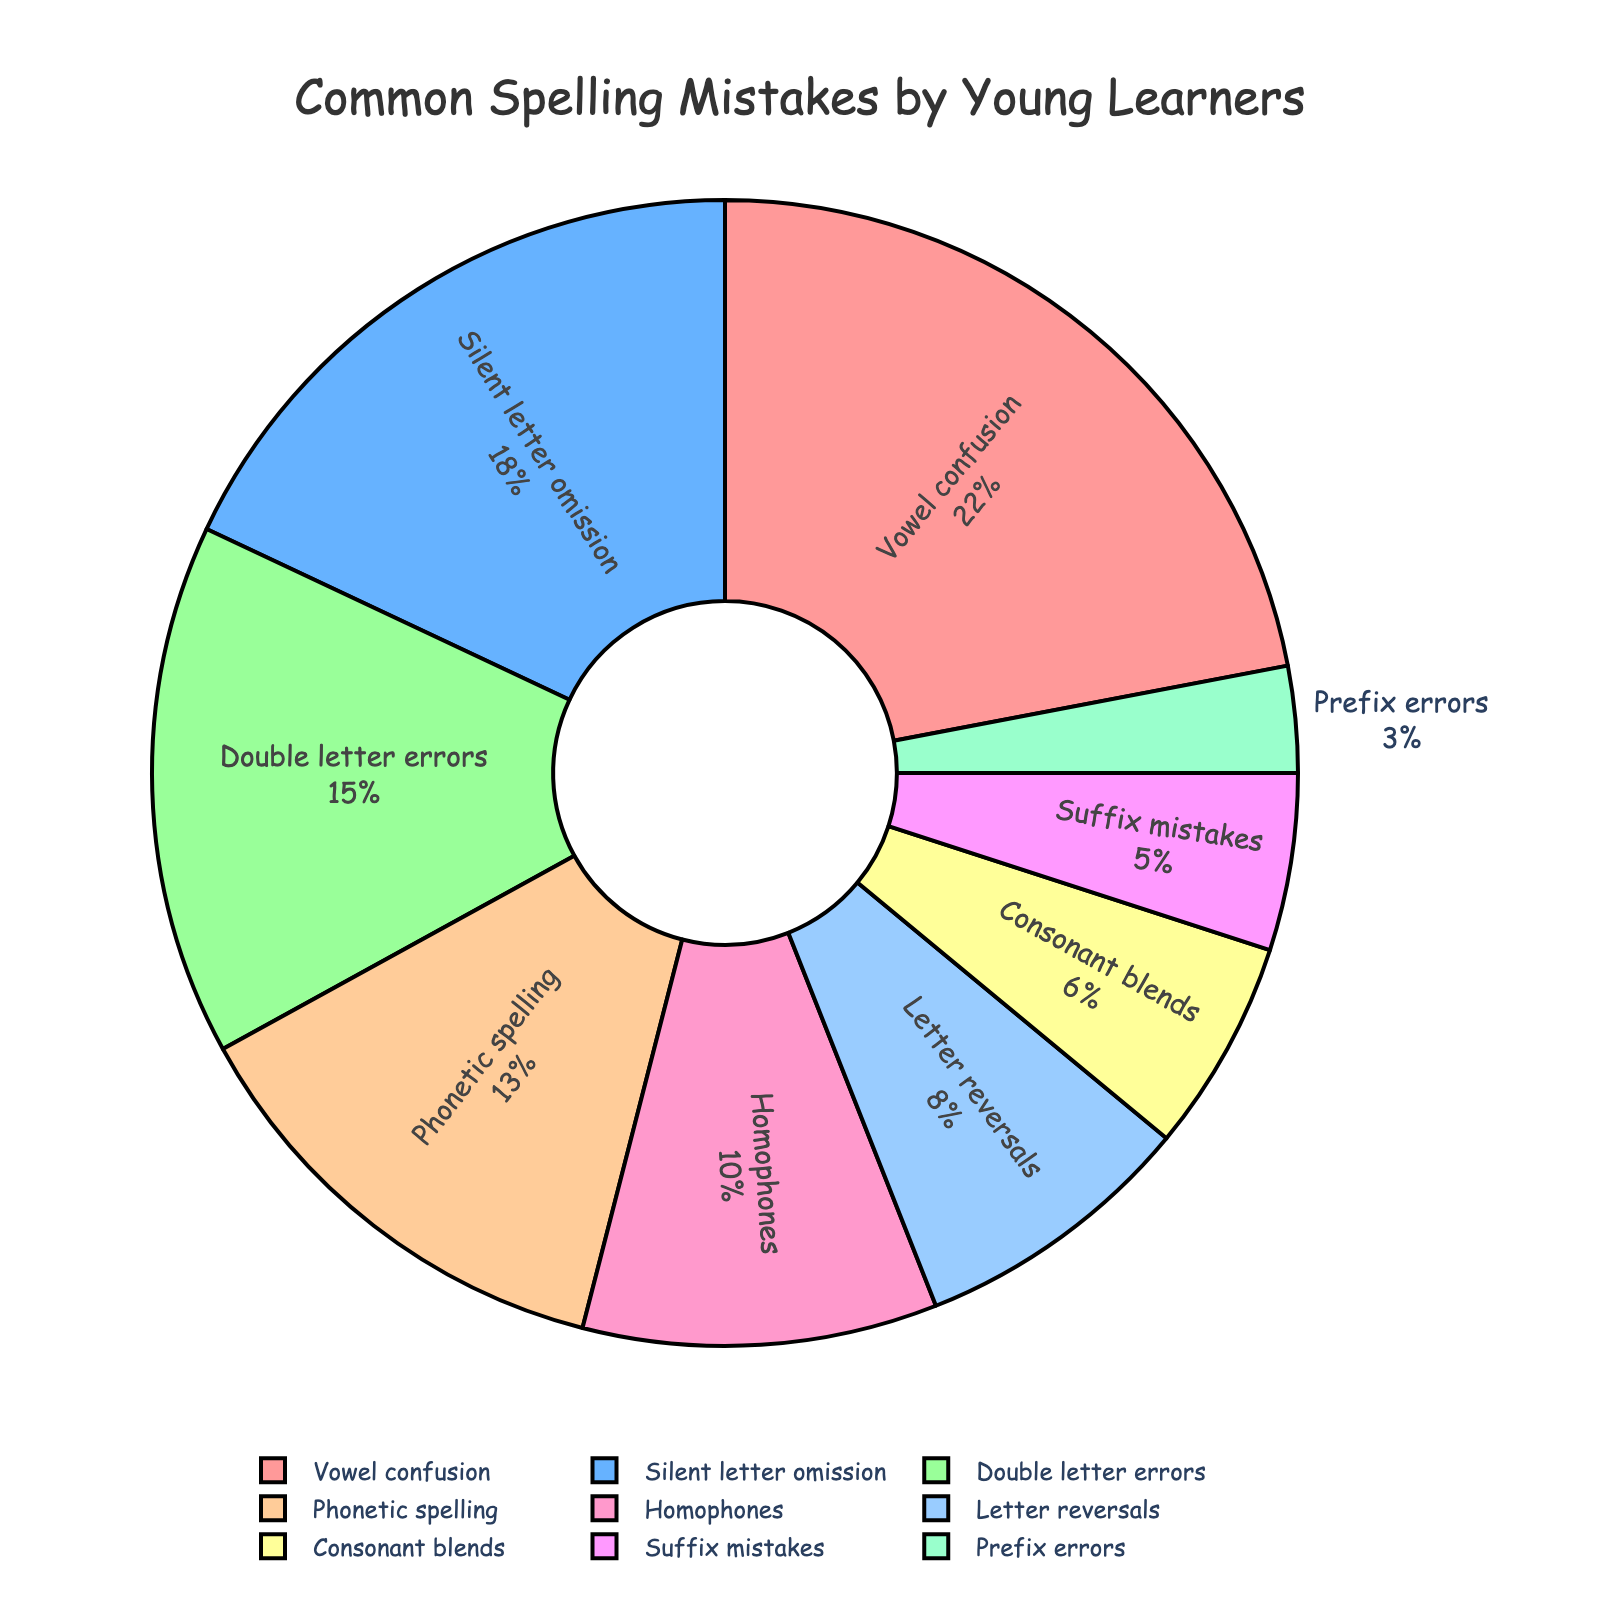How much more percentage of mistakes does 'Vowel confusion' have compared to 'Silent letter omission'? 'Vowel confusion' has 22% and 'Silent letter omission' has 18%. The difference is 22% - 18% = 4%.
Answer: 4% Which category has the smallest percentage of mistakes, and what is that percentage? By looking at the chart, the smallest slice corresponds to 'Prefix errors', which has a percentage of 3%.
Answer: Prefix errors with 3% What is the total percentage of mistakes made up by 'Phonetic spelling', 'Homophones', and 'Letter reversals'? 'Phonetic spelling' has 13%, 'Homophones' have 10%, and 'Letter reversals' have 8%. Adding these together: 13% + 10% + 8% = 31%.
Answer: 31% Which segment appears in green color and what is its percentage? By looking at the colors assigned to the categories, the green segment corresponds to 'Homophones' with 10%.
Answer: Homophones, 10% Which two categories have the closest percentage values, and what are these percentages? 'Silent letter omission' has 18% and 'Double letter errors' have 15%. The difference is only 3% between these two categories, which is the smallest observed difference.
Answer: Silent letter omission (18%) and Double letter errors (15%) Is the percentage of 'Double letter errors' greater than the percentage of 'Phonetic spelling'? 'Double letter errors' has 15% and 'Phonetic spelling' has 13%. 15% is indeed greater than 13%.
Answer: Yes What is the combined percentage of the smallest three categories in the chart? The three smallest categories are 'Prefix errors' (3%), 'Suffix mistakes' (5%), and 'Consonant blends' (6%). Their combined percentage is 3% + 5% + 6% = 14%.
Answer: 14% Which category, represented by a pinkish color, has a relatively higher percentage associated with it? The slice with the pinkish color (FF9999) represents 'Vowel confusion' which has a percentage of 22%.
Answer: Vowel confusion If you combine the percentages of 'Silent letter omission' and 'Double letter errors', is the result higher or lower than the percentage of 'Vowel confusion'? 'Silent letter omission' has 18%, and 'Double letter errors' has 15%. Together they sum up to 18% + 15% = 33%, which is higher than 'Vowel confusion' at 22%.
Answer: Higher 